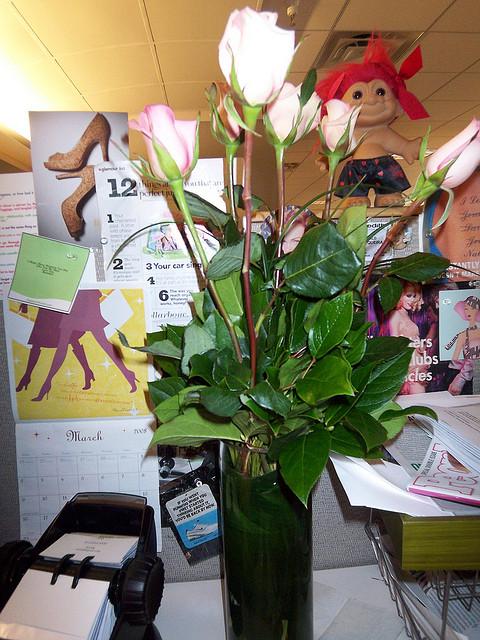What color is the doll's hair?
Concise answer only. Red. What color is the flowers?
Give a very brief answer. Pink. What are they in?
Keep it brief. Vase. 